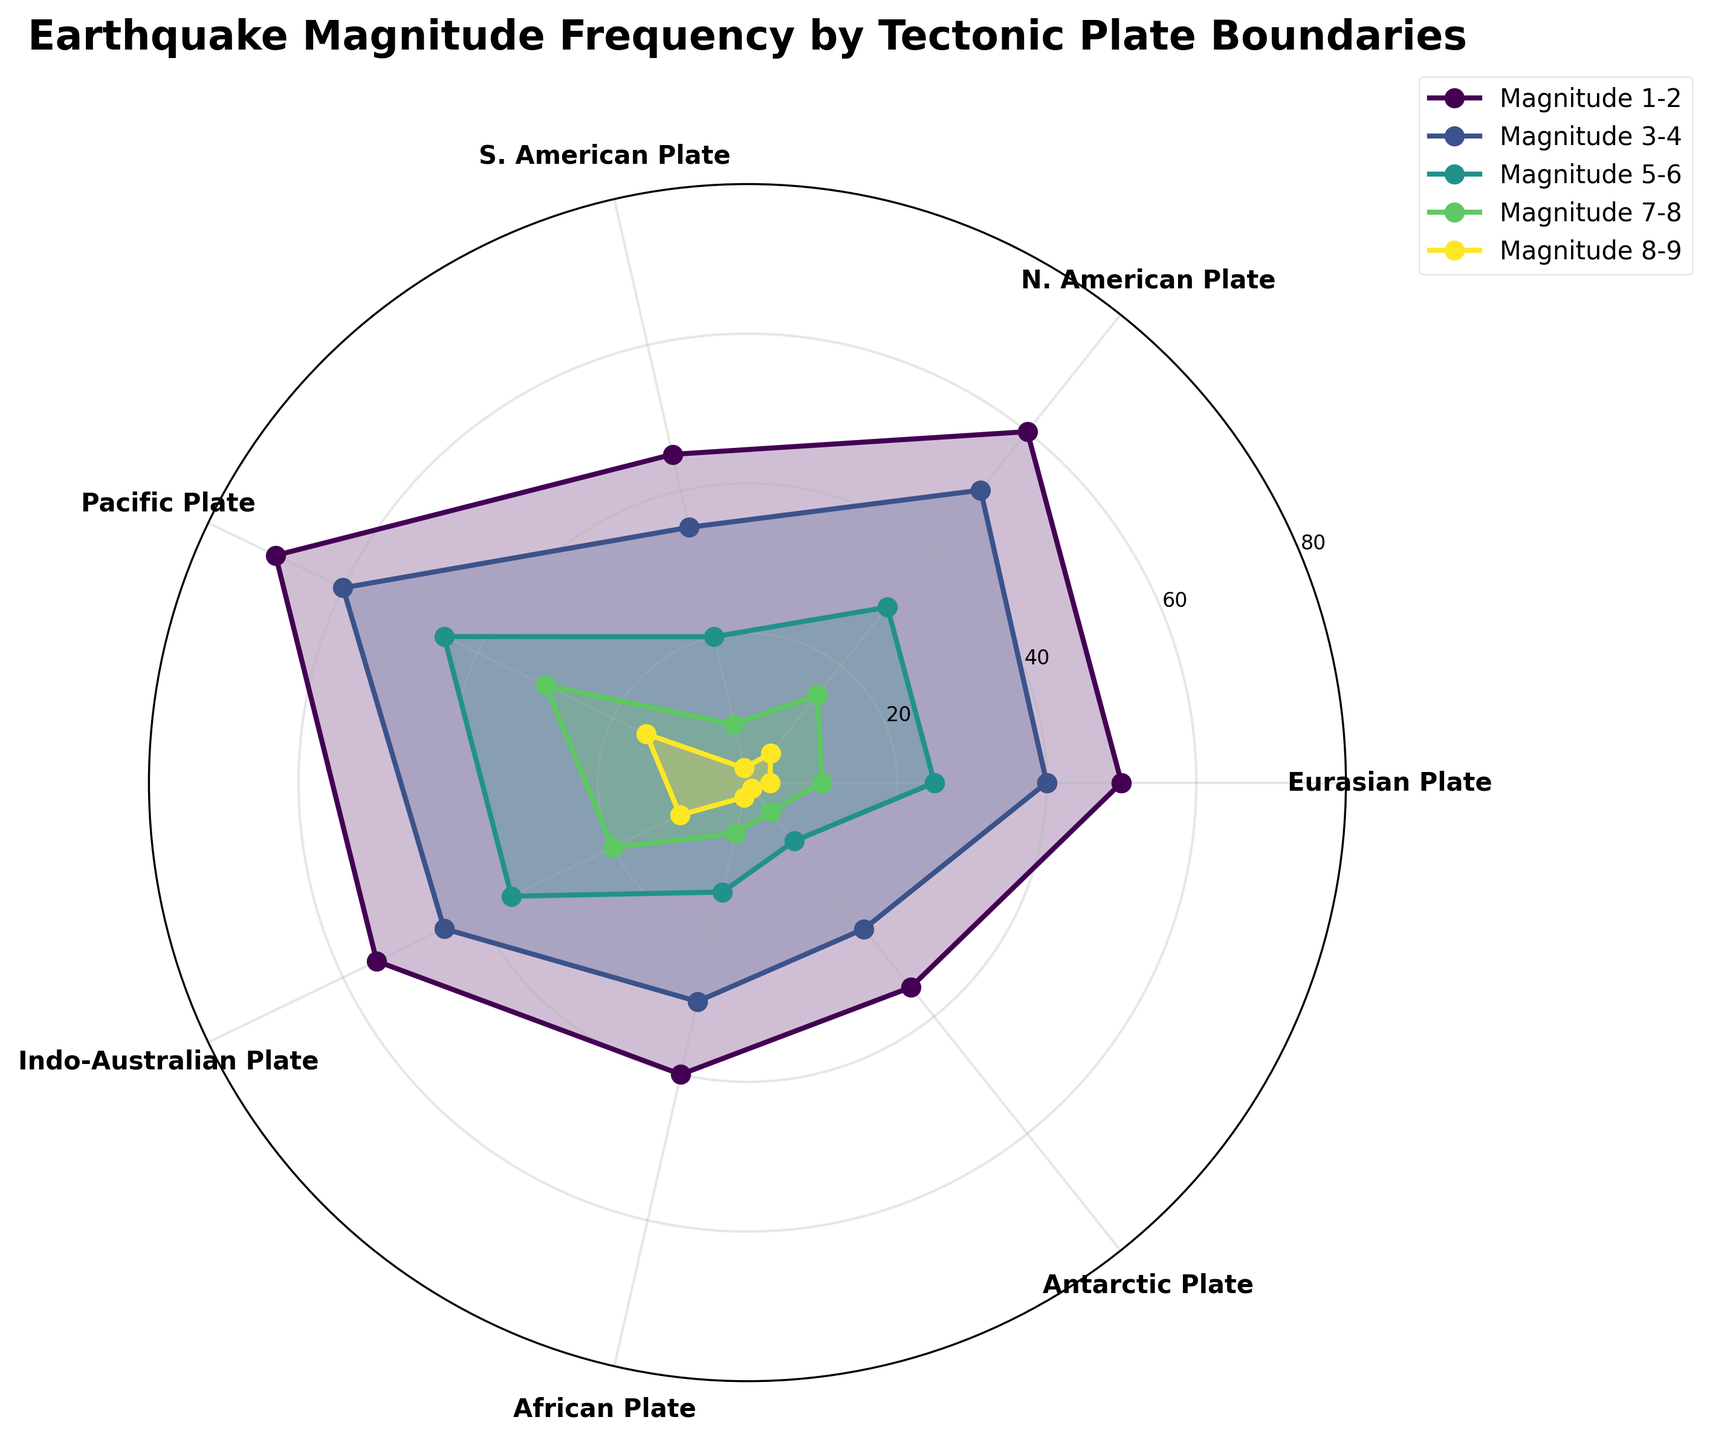What is the title of the radar chart? The title is usually located at the top of the chart. In this case, read the text that is bold and positioned centrally above the plot.
Answer: Earthquake Magnitude Frequency by Tectonic Plate Boundaries What tectonic plate has the highest frequency for Magnitude 1-2 earthquakes? Look at the outermost line in the radar chart that represents Magnitude 1-2 earthquakes and find the data point on the radar chart with the maximum value.
Answer: Pacific Plate Which earthquake magnitude category has the least frequency for the Antarctic Plate? Identify the segment of the chart corresponding to the Antarctic Plate and find the smallest value among the earthquake magnitudes from Magnitude 1-2 through Magnitude 8-9.
Answer: Magnitude 8-9 How does the frequency of Magnitude 3-4 earthquakes compare between the Eurasian Plate and the African Plate? Find the data points for Magnitude 3-4 earthquakes for both the Eurasian Plate and the African Plate and then compare the values.
Answer: Eurasian Plate has a higher frequency Are there more Magnitude 5-6 earthquakes on the Indo-Australian Plate or the Antarctic Plate? Examine both the Indo-Australian Plate and the Antarctic Plate on the Magnitude 5-6 segment and compare the values directly.
Answer: Indo-Australian Plate What is the average frequency of Magnitude 7-8 earthquakes across all plates? Sum the frequencies of Magnitude 7-8 earthquakes for all plates and then divide by the number of plates (7). Calculation: (10 + 15 + 8 + 30 + 20 + 7 + 5) / 7 = 13.57
Answer: 13.57 Which plate shows the greatest difference in earthquake frequency between Magnitude 1-2 and Magnitude 8-9? For each plate, subtract the value of Magnitude 8-9 earthquakes from that of Magnitude 1-2 earthquakes, and identify the plate with the maximum difference.
Answer: Pacific Plate How many Boundary Types are represented in the radar chart? Count the number of lines/patterns in the legend at the top right of the chart, which represent different boundary types.
Answer: 7 What is the frequency of Magnitude 8-9 earthquakes on the N. American Plate? Locate the data point on the magnitude line for Magnitude 8-9 and corresponding to the N. American Plate.
Answer: 5 From the data, is the Eurasian Plate or the S. American Plate more prone to larger Magnitude (7-8 and 8-9) earthquakes? Compare the sum of frequencies for Magnitude 7-8 and 8-9 earthquakes for the Eurasian Plate and S. American Plate respectively. Calculation: Eurasian Plate: 10+3=13, S. American Plate: 8+2=10
Answer: Eurasian Plate 